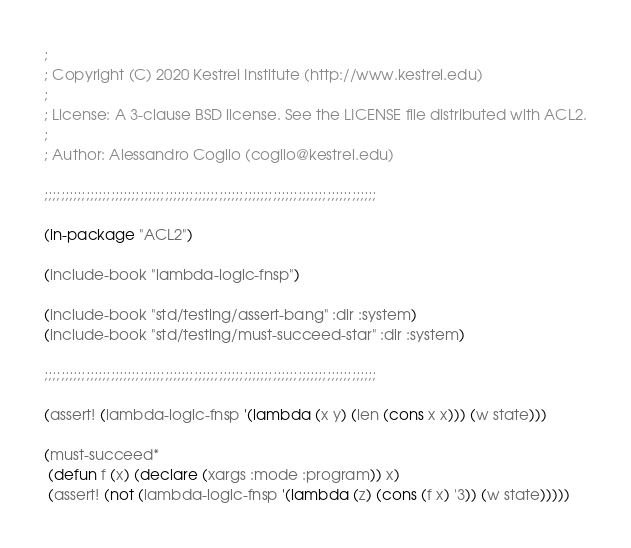<code> <loc_0><loc_0><loc_500><loc_500><_Lisp_>;
; Copyright (C) 2020 Kestrel Institute (http://www.kestrel.edu)
;
; License: A 3-clause BSD license. See the LICENSE file distributed with ACL2.
;
; Author: Alessandro Coglio (coglio@kestrel.edu)

;;;;;;;;;;;;;;;;;;;;;;;;;;;;;;;;;;;;;;;;;;;;;;;;;;;;;;;;;;;;;;;;;;;;;;;;;;;;;;;;

(in-package "ACL2")

(include-book "lambda-logic-fnsp")

(include-book "std/testing/assert-bang" :dir :system)
(include-book "std/testing/must-succeed-star" :dir :system)

;;;;;;;;;;;;;;;;;;;;;;;;;;;;;;;;;;;;;;;;;;;;;;;;;;;;;;;;;;;;;;;;;;;;;;;;;;;;;;;;

(assert! (lambda-logic-fnsp '(lambda (x y) (len (cons x x))) (w state)))

(must-succeed*
 (defun f (x) (declare (xargs :mode :program)) x)
 (assert! (not (lambda-logic-fnsp '(lambda (z) (cons (f x) '3)) (w state)))))
</code> 